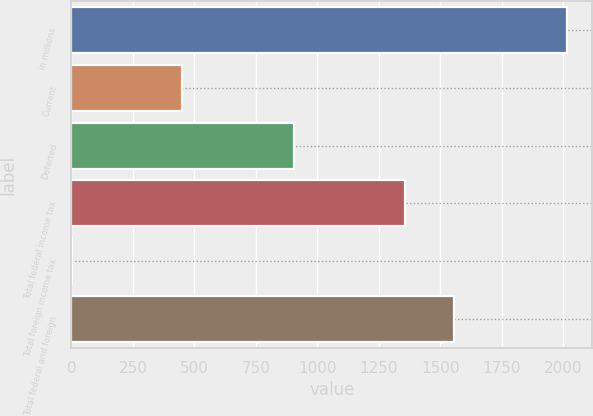<chart> <loc_0><loc_0><loc_500><loc_500><bar_chart><fcel>in millions<fcel>Current<fcel>Deferred<fcel>Total federal income tax<fcel>Total foreign income tax<fcel>Total federal and foreign<nl><fcel>2017<fcel>449<fcel>907<fcel>1356<fcel>4<fcel>1557.3<nl></chart> 